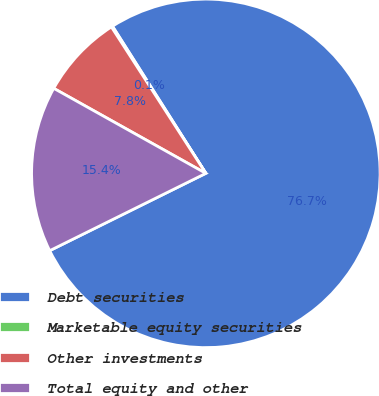<chart> <loc_0><loc_0><loc_500><loc_500><pie_chart><fcel>Debt securities<fcel>Marketable equity securities<fcel>Other investments<fcel>Total equity and other<nl><fcel>76.68%<fcel>0.12%<fcel>7.77%<fcel>15.43%<nl></chart> 